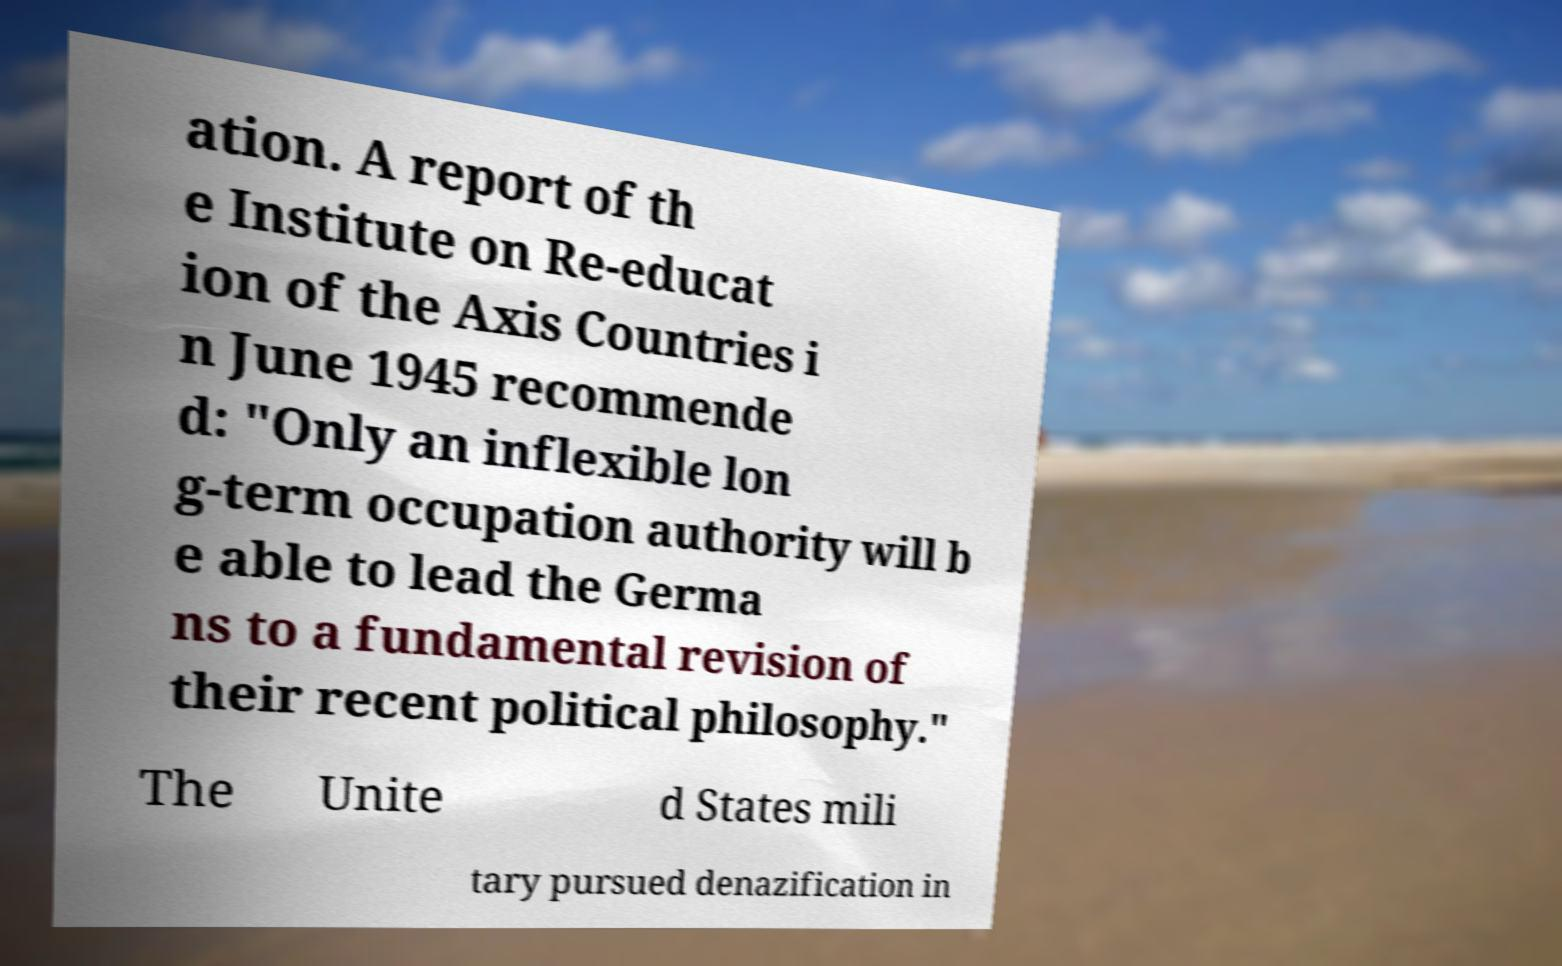Could you extract and type out the text from this image? ation. A report of th e Institute on Re-educat ion of the Axis Countries i n June 1945 recommende d: "Only an inflexible lon g-term occupation authority will b e able to lead the Germa ns to a fundamental revision of their recent political philosophy." The Unite d States mili tary pursued denazification in 